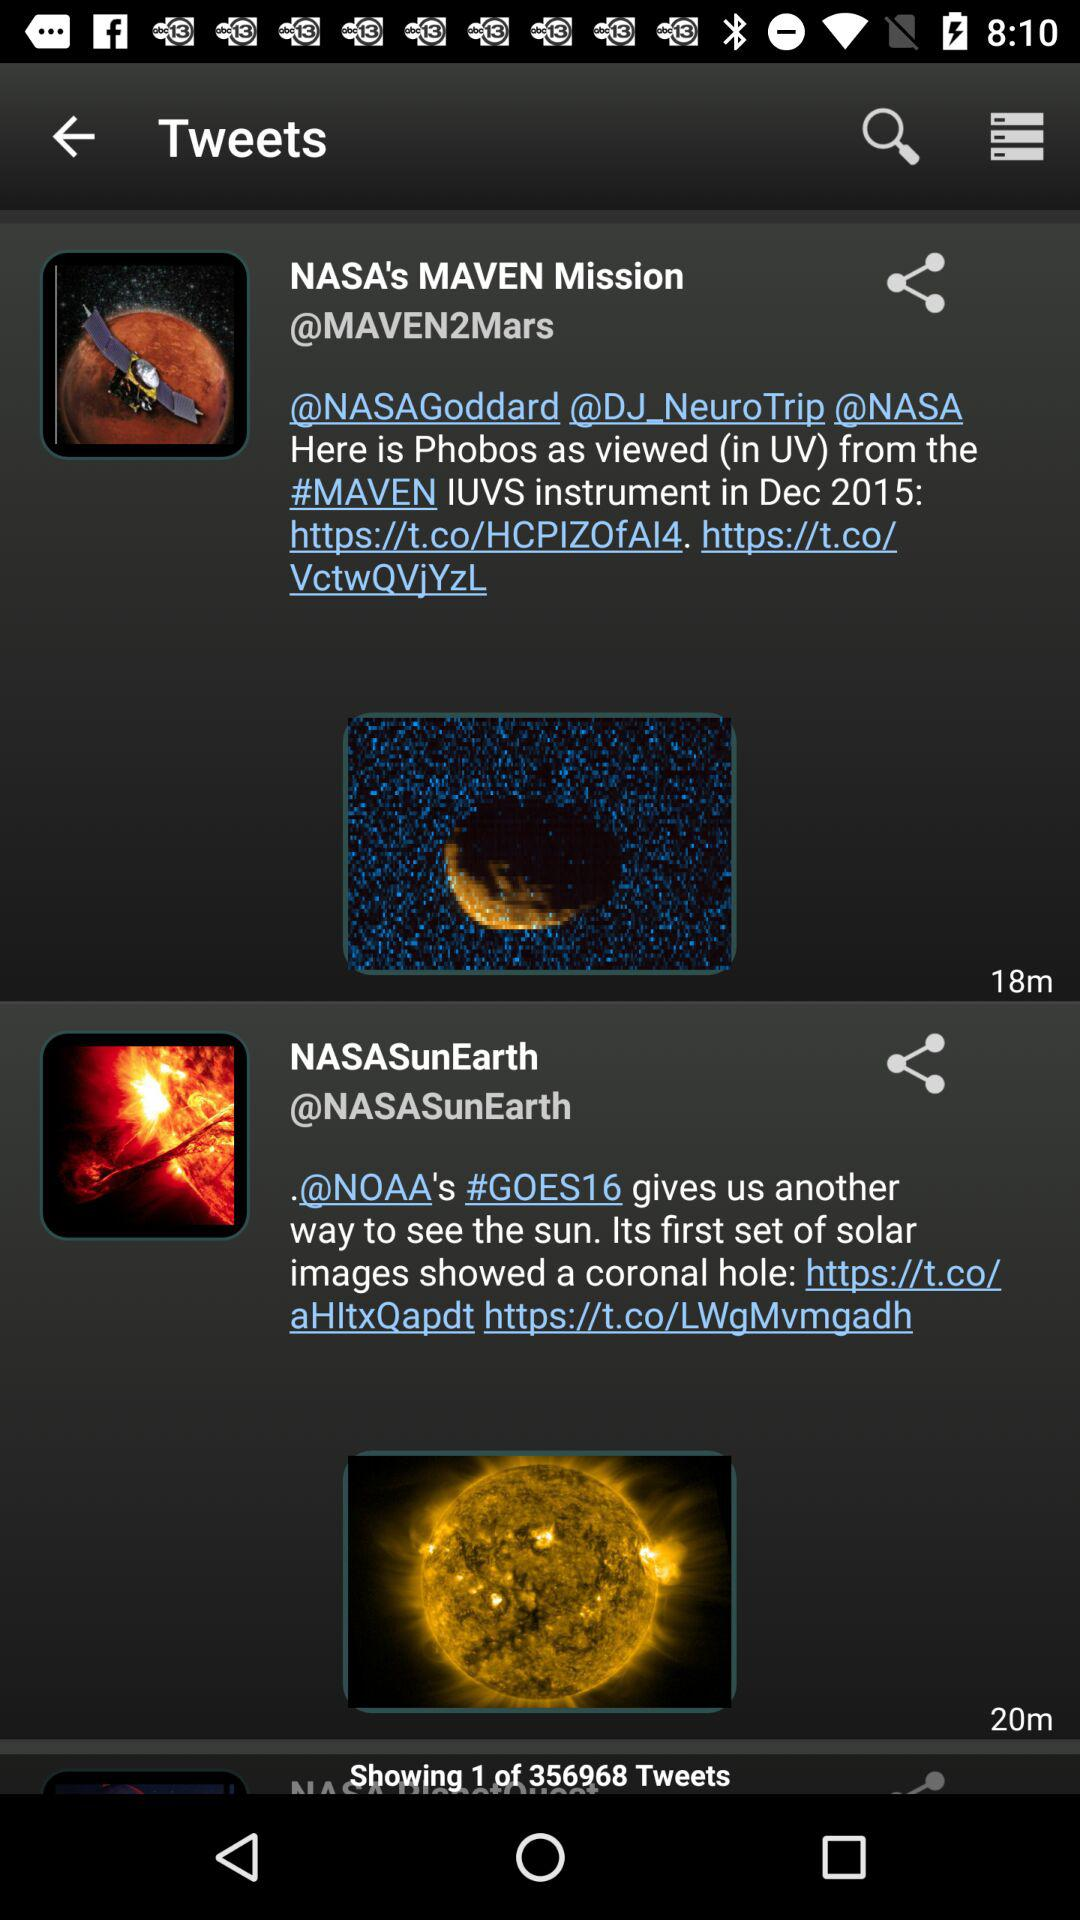How many tweets are there in total? There are 356968 tweets in total. 